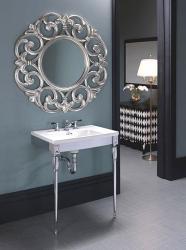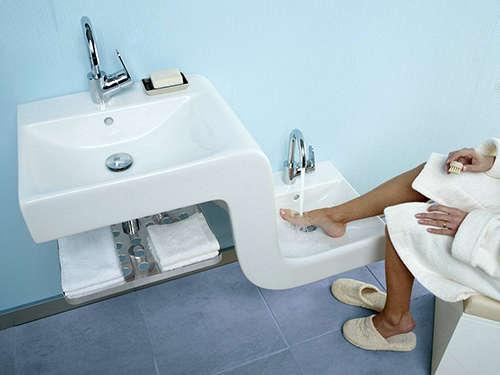The first image is the image on the left, the second image is the image on the right. For the images shown, is this caption "There is a frame on the wall in the image on the left." true? Answer yes or no. No. The first image is the image on the left, the second image is the image on the right. For the images displayed, is the sentence "Neither picture contains a mirror that is shaped like a circle or an oval." factually correct? Answer yes or no. No. 